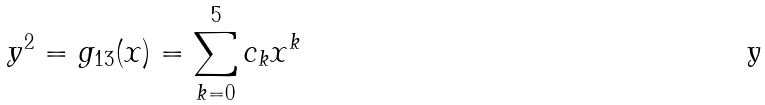Convert formula to latex. <formula><loc_0><loc_0><loc_500><loc_500>y ^ { 2 } = g _ { 1 3 } ( x ) = \sum _ { k = 0 } ^ { 5 } c _ { k } x ^ { k }</formula> 